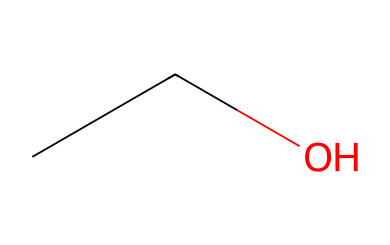What is the molecular formula of this chemical? The SMILES representation "CCO" indicates there are 2 carbon atoms (C) and 6 hydrogen atoms (H) along with 1 oxygen atom (O), which gives the molecular formula C2H6O.
Answer: C2H6O How many hydrogen atoms are in this molecule? Analyzing the SMILES "CCO," there are three hydrogen atoms attached to each carbon atom (a total of 5 from both carbons) and one hydrogen attached to the oxygen's hydroxyl group, leading to a total of 6 hydrogen atoms.
Answer: 6 What functional group is present in this chemical? Looking at the structure indicated in the SMILES, the presence of the "OH" group signifies that this molecule contains a hydroxyl functional group, which is characteristic of alcohols.
Answer: hydroxyl Is this chemical flammable? Ethanol, represented by the SMILES "CCO," is classified as a flammable liquid due to its chemical structure that allows it to ignite easily under the right conditions.
Answer: yes What type of intermolecular forces are present in this chemical? The chemical structure of ethanol suggests the presence of hydrogen bonding due to the hydroxyl group (-OH) interacting with other ethanol molecules, in addition to London dispersion forces.
Answer: hydrogen bonding What state of matter is this chemical at room temperature? Ethanol, indicated by the SMILES "CCO," is typically a liquid at room temperature, which is supported by its molecular size and the viscosity associated with alcohols.
Answer: liquid 